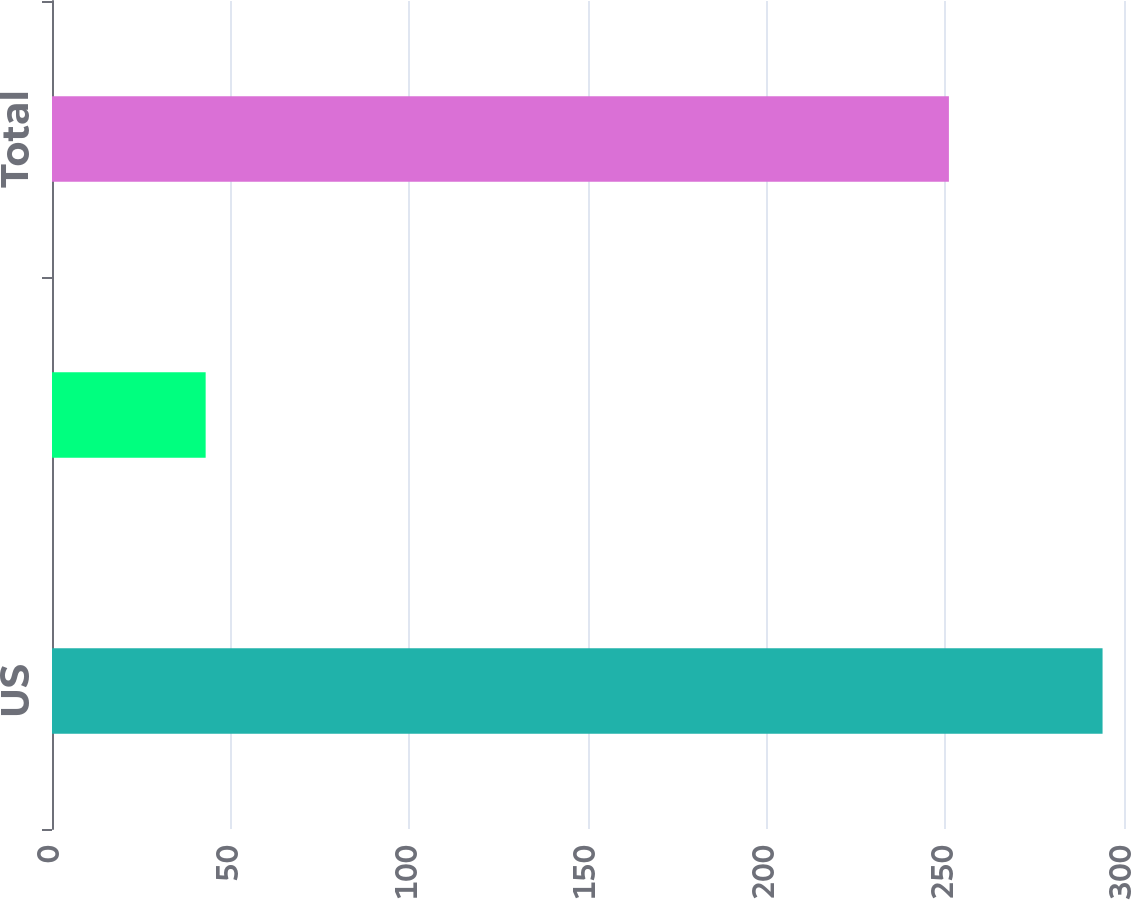Convert chart to OTSL. <chart><loc_0><loc_0><loc_500><loc_500><bar_chart><fcel>US<fcel>International<fcel>Total<nl><fcel>294<fcel>43<fcel>251<nl></chart> 